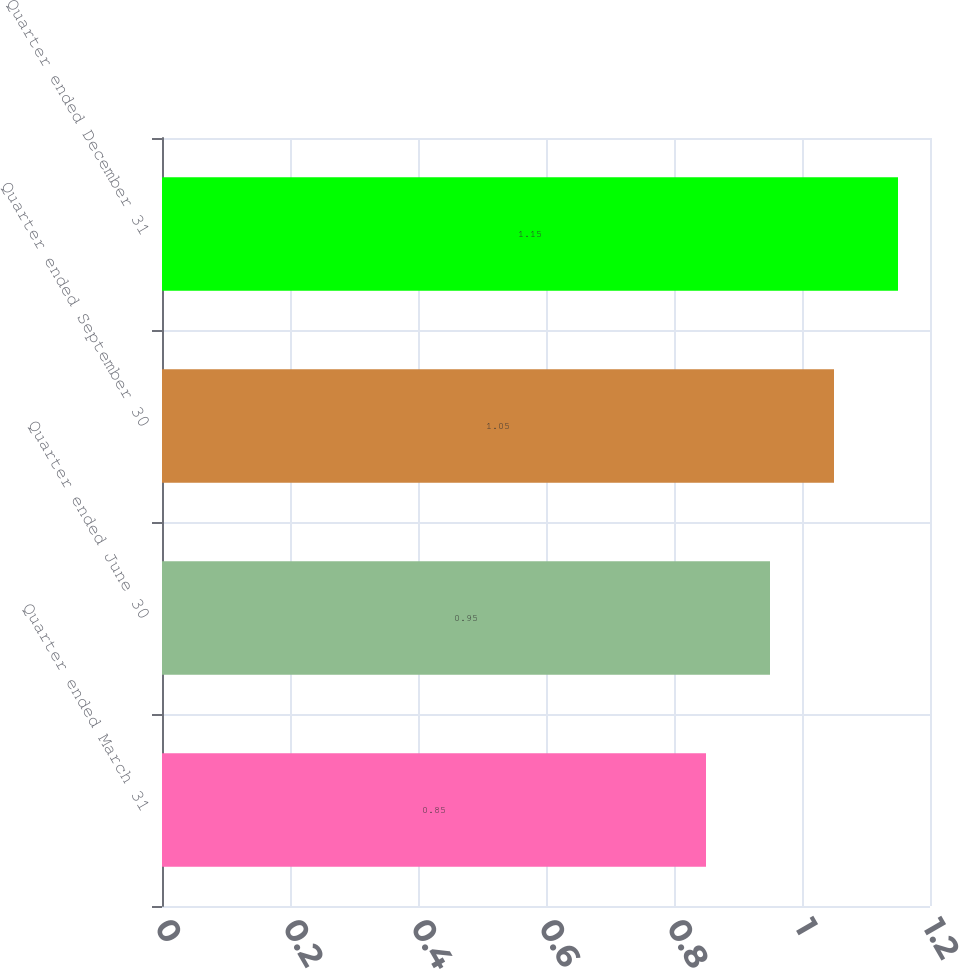<chart> <loc_0><loc_0><loc_500><loc_500><bar_chart><fcel>Quarter ended March 31<fcel>Quarter ended June 30<fcel>Quarter ended September 30<fcel>Quarter ended December 31<nl><fcel>0.85<fcel>0.95<fcel>1.05<fcel>1.15<nl></chart> 